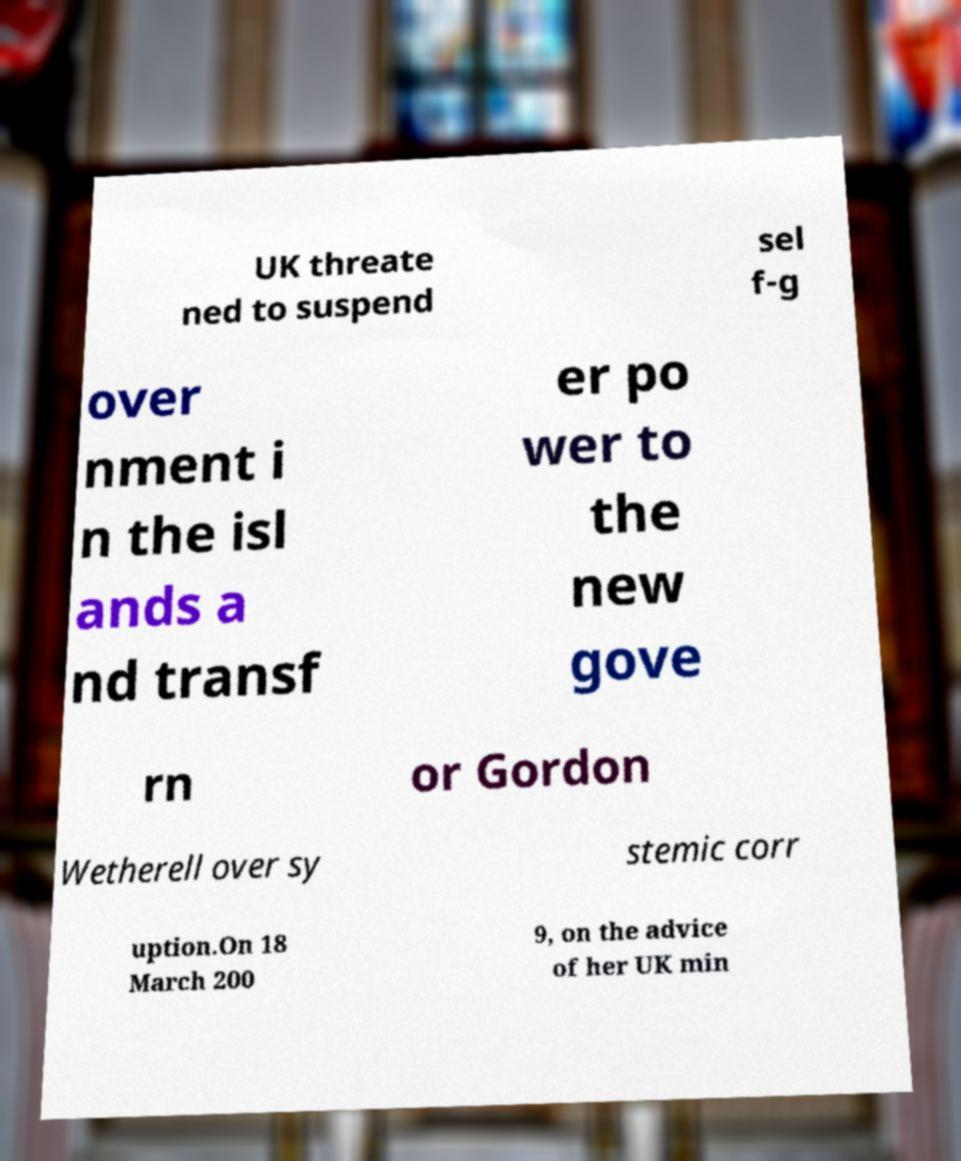There's text embedded in this image that I need extracted. Can you transcribe it verbatim? UK threate ned to suspend sel f-g over nment i n the isl ands a nd transf er po wer to the new gove rn or Gordon Wetherell over sy stemic corr uption.On 18 March 200 9, on the advice of her UK min 